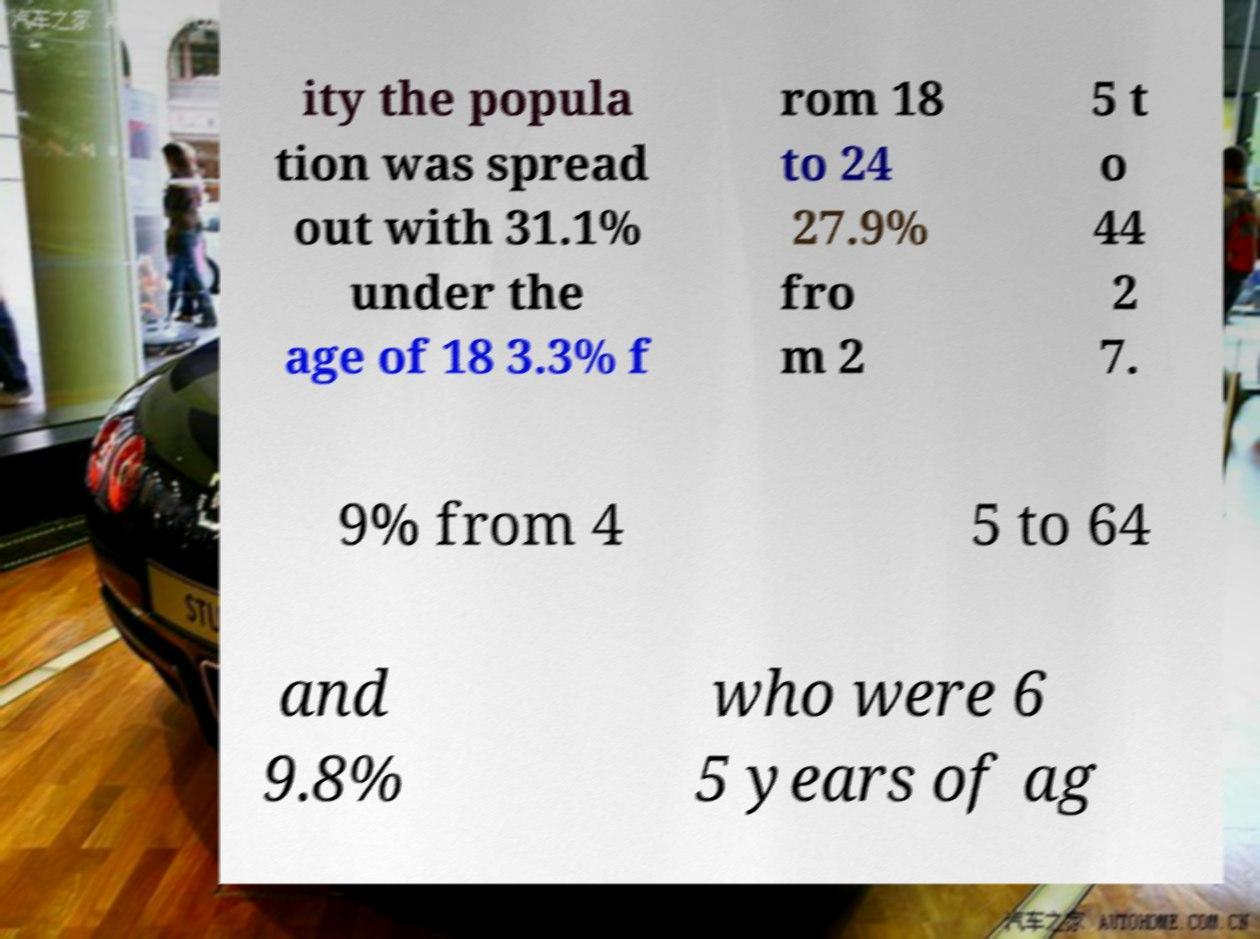What messages or text are displayed in this image? I need them in a readable, typed format. ity the popula tion was spread out with 31.1% under the age of 18 3.3% f rom 18 to 24 27.9% fro m 2 5 t o 44 2 7. 9% from 4 5 to 64 and 9.8% who were 6 5 years of ag 